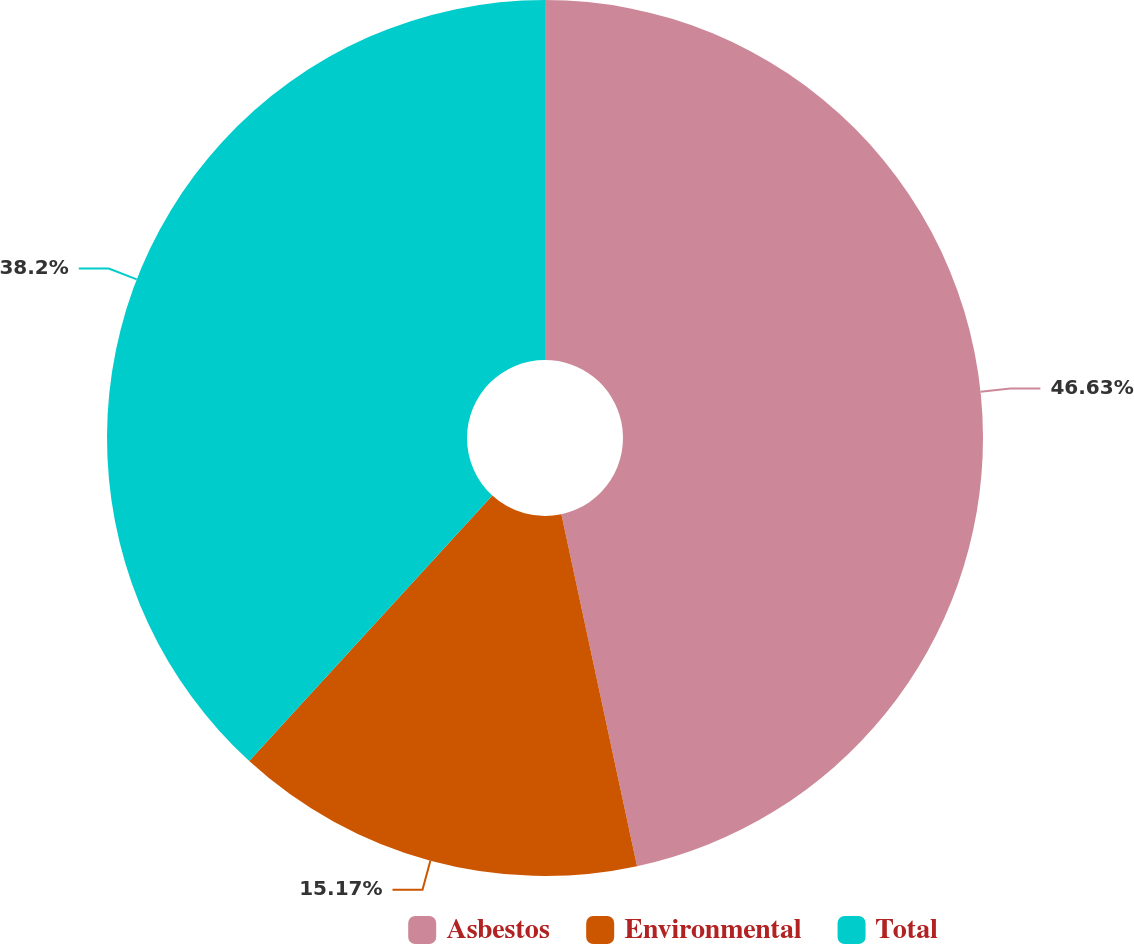Convert chart to OTSL. <chart><loc_0><loc_0><loc_500><loc_500><pie_chart><fcel>Asbestos<fcel>Environmental<fcel>Total<nl><fcel>46.63%<fcel>15.17%<fcel>38.2%<nl></chart> 